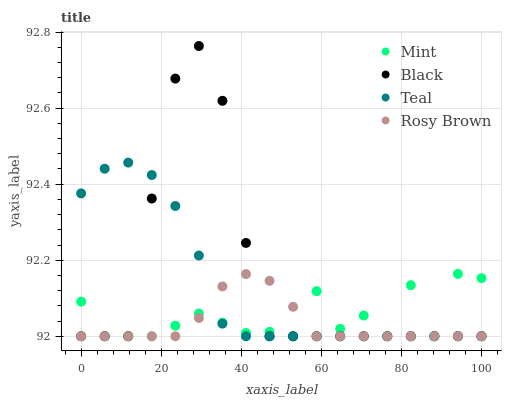Does Rosy Brown have the minimum area under the curve?
Answer yes or no. Yes. Does Black have the maximum area under the curve?
Answer yes or no. Yes. Does Mint have the minimum area under the curve?
Answer yes or no. No. Does Mint have the maximum area under the curve?
Answer yes or no. No. Is Rosy Brown the smoothest?
Answer yes or no. Yes. Is Mint the roughest?
Answer yes or no. Yes. Is Mint the smoothest?
Answer yes or no. No. Is Rosy Brown the roughest?
Answer yes or no. No. Does Black have the lowest value?
Answer yes or no. Yes. Does Black have the highest value?
Answer yes or no. Yes. Does Mint have the highest value?
Answer yes or no. No. Does Teal intersect Rosy Brown?
Answer yes or no. Yes. Is Teal less than Rosy Brown?
Answer yes or no. No. Is Teal greater than Rosy Brown?
Answer yes or no. No. 